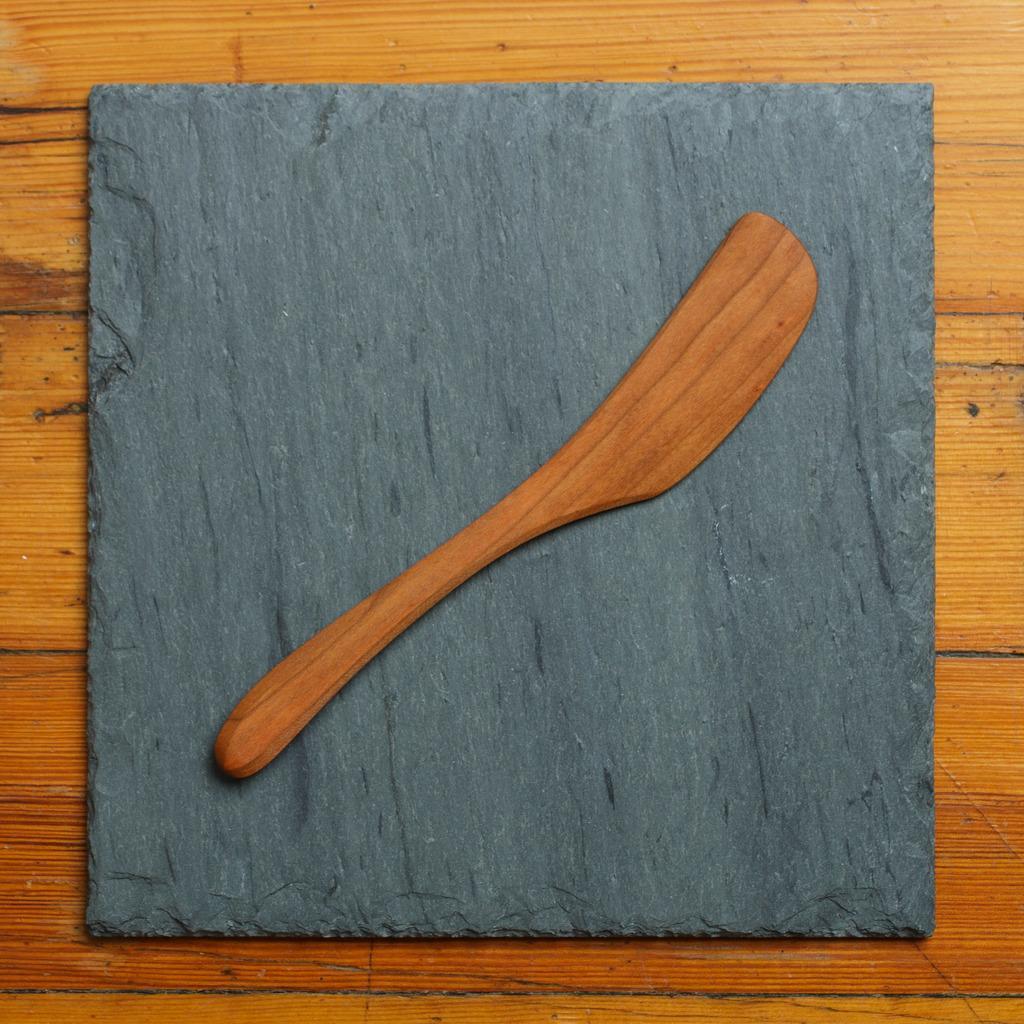Describe this image in one or two sentences. In this image, we can see wooden spatula on the marble. This marble is placed on the wooden object. 